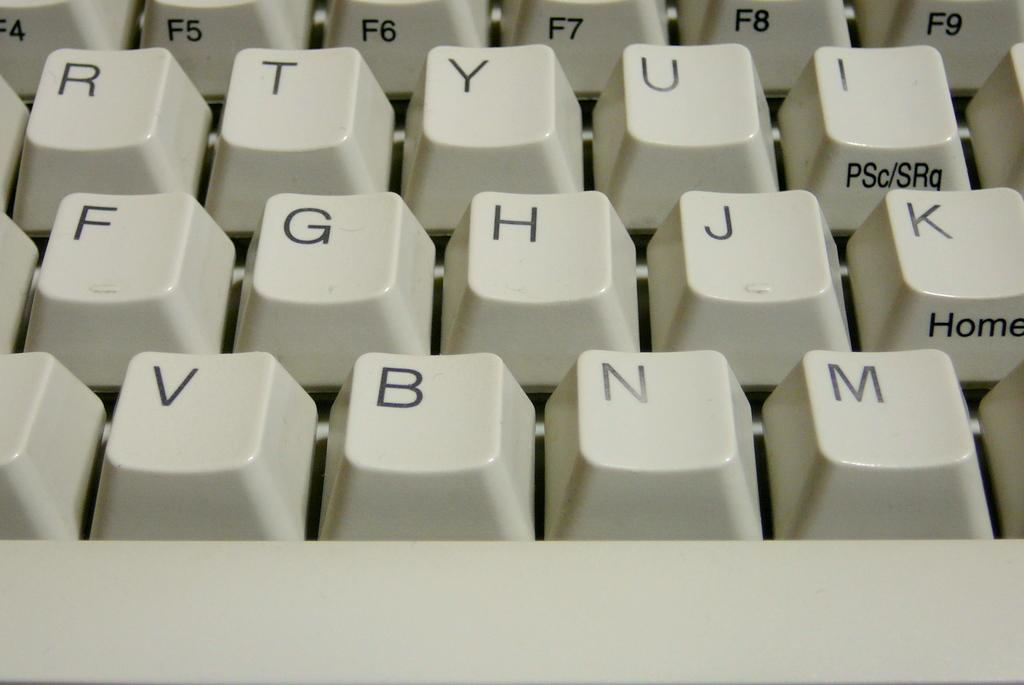<image>
Render a clear and concise summary of the photo. A keyboard with the word home written on the K key. 